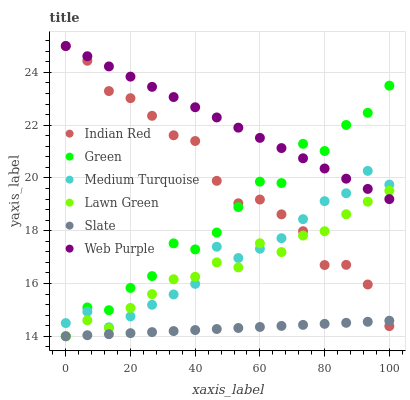Does Slate have the minimum area under the curve?
Answer yes or no. Yes. Does Web Purple have the maximum area under the curve?
Answer yes or no. Yes. Does Indian Red have the minimum area under the curve?
Answer yes or no. No. Does Indian Red have the maximum area under the curve?
Answer yes or no. No. Is Slate the smoothest?
Answer yes or no. Yes. Is Green the roughest?
Answer yes or no. Yes. Is Indian Red the smoothest?
Answer yes or no. No. Is Indian Red the roughest?
Answer yes or no. No. Does Lawn Green have the lowest value?
Answer yes or no. Yes. Does Indian Red have the lowest value?
Answer yes or no. No. Does Web Purple have the highest value?
Answer yes or no. Yes. Does Slate have the highest value?
Answer yes or no. No. Is Slate less than Web Purple?
Answer yes or no. Yes. Is Medium Turquoise greater than Slate?
Answer yes or no. Yes. Does Lawn Green intersect Web Purple?
Answer yes or no. Yes. Is Lawn Green less than Web Purple?
Answer yes or no. No. Is Lawn Green greater than Web Purple?
Answer yes or no. No. Does Slate intersect Web Purple?
Answer yes or no. No. 